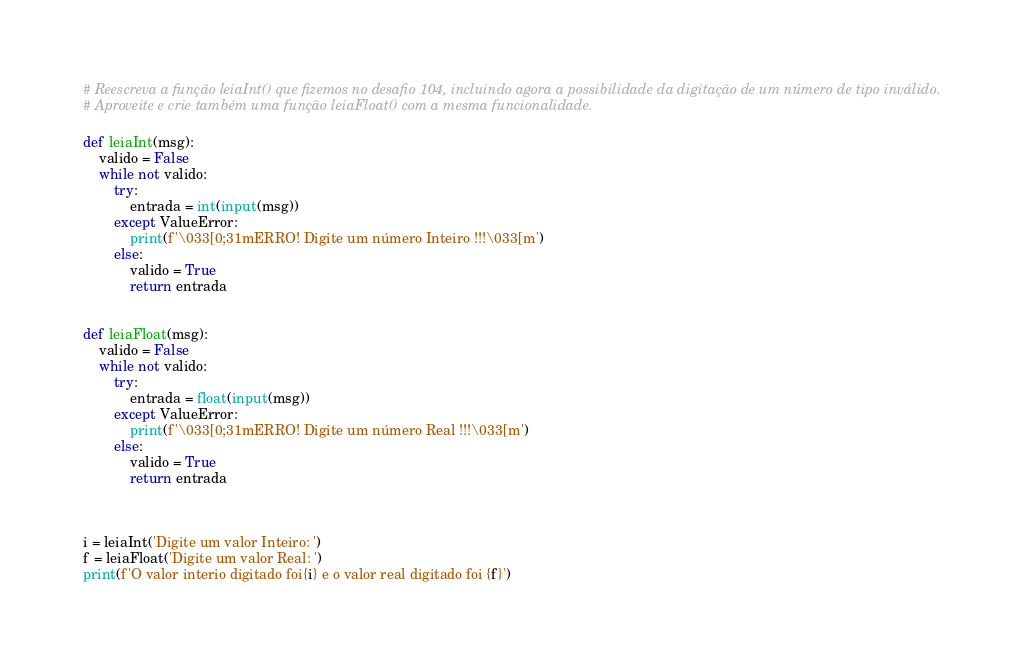Convert code to text. <code><loc_0><loc_0><loc_500><loc_500><_Python_># Reescreva a função leiaInt() que fizemos no desafio 104, incluindo agora a possibilidade da digitação de um número de tipo inválido.
# Aproveite e crie também uma função leiaFloat() com a mesma funcionalidade.

def leiaInt(msg):
    valido = False
    while not valido:
        try:
            entrada = int(input(msg))
        except ValueError:
            print(f'\033[0;31mERRO! Digite um número Inteiro !!!\033[m')
        else:
            valido = True
            return entrada


def leiaFloat(msg):
    valido = False
    while not valido:
        try:
            entrada = float(input(msg))
        except ValueError:
            print(f'\033[0;31mERRO! Digite um número Real !!!\033[m')
        else:
            valido = True
            return entrada



i = leiaInt('Digite um valor Inteiro: ')
f = leiaFloat('Digite um valor Real: ')
print(f'O valor interio digitado foi{i} e o valor real digitado foi {f}')

</code> 